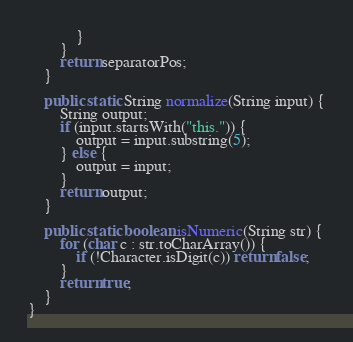Convert code to text. <code><loc_0><loc_0><loc_500><loc_500><_Java_>            }
        }
        return separatorPos;
    }

    public static String normalize(String input) {
        String output;
        if (input.startsWith("this.")) {
            output = input.substring(5);
        } else {
            output = input;
        }
        return output;
    }

    public static boolean isNumeric(String str) {
        for (char c : str.toCharArray()) {
            if (!Character.isDigit(c)) return false;
        }
        return true;
    }
}
</code> 